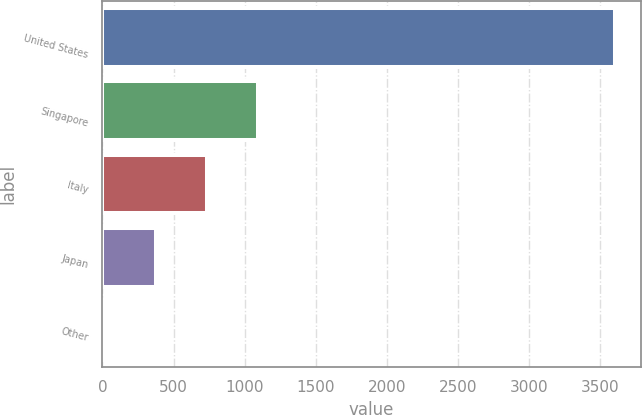Convert chart to OTSL. <chart><loc_0><loc_0><loc_500><loc_500><bar_chart><fcel>United States<fcel>Singapore<fcel>Italy<fcel>Japan<fcel>Other<nl><fcel>3604<fcel>1091.56<fcel>732.64<fcel>373.72<fcel>14.8<nl></chart> 